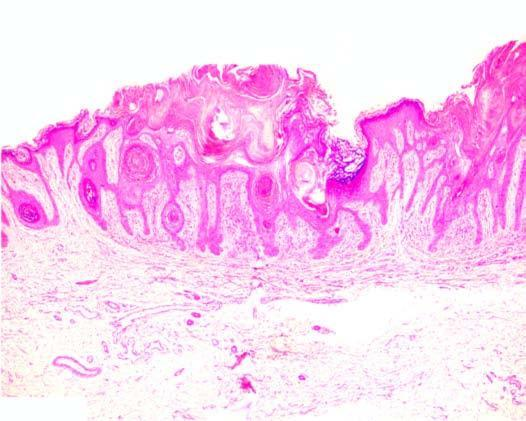what include papillomatosis, hyperkeratosis and acanthosis?
Answer the question using a single word or phrase. Other features 